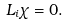Convert formula to latex. <formula><loc_0><loc_0><loc_500><loc_500>L _ { i } \chi = 0 .</formula> 